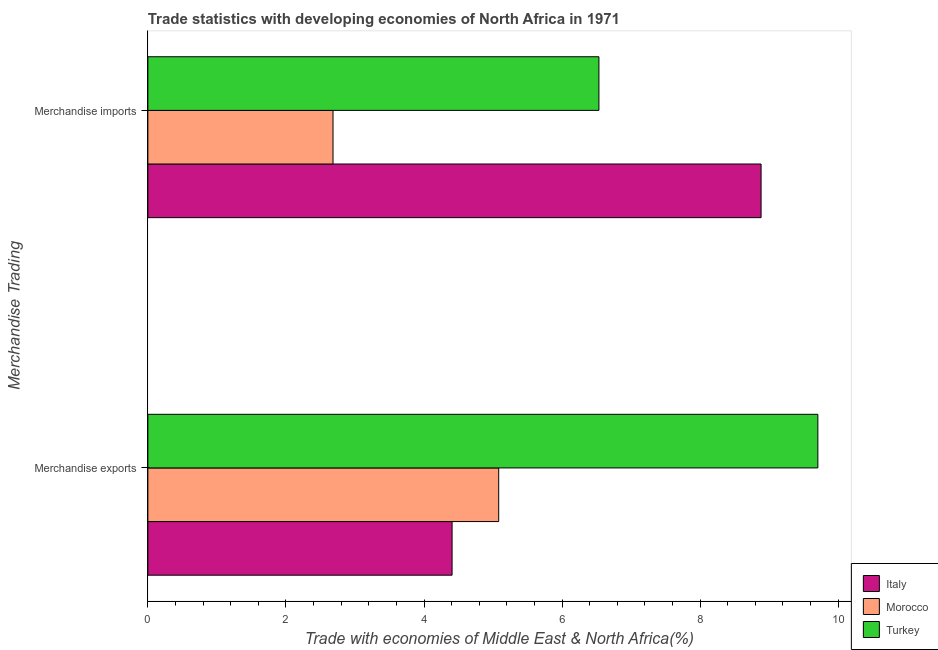How many different coloured bars are there?
Ensure brevity in your answer.  3. How many groups of bars are there?
Offer a terse response. 2. Are the number of bars per tick equal to the number of legend labels?
Offer a very short reply. Yes. How many bars are there on the 1st tick from the top?
Provide a short and direct response. 3. How many bars are there on the 1st tick from the bottom?
Your response must be concise. 3. What is the merchandise exports in Morocco?
Give a very brief answer. 5.08. Across all countries, what is the maximum merchandise exports?
Your answer should be compact. 9.71. Across all countries, what is the minimum merchandise imports?
Give a very brief answer. 2.68. In which country was the merchandise exports maximum?
Make the answer very short. Turkey. In which country was the merchandise imports minimum?
Keep it short and to the point. Morocco. What is the total merchandise imports in the graph?
Make the answer very short. 18.1. What is the difference between the merchandise imports in Turkey and that in Italy?
Your answer should be very brief. -2.35. What is the difference between the merchandise exports in Morocco and the merchandise imports in Italy?
Provide a short and direct response. -3.8. What is the average merchandise exports per country?
Make the answer very short. 6.4. What is the difference between the merchandise exports and merchandise imports in Morocco?
Offer a terse response. 2.4. In how many countries, is the merchandise exports greater than 1.2000000000000002 %?
Provide a succinct answer. 3. What is the ratio of the merchandise exports in Italy to that in Morocco?
Your response must be concise. 0.87. In how many countries, is the merchandise exports greater than the average merchandise exports taken over all countries?
Make the answer very short. 1. What does the 1st bar from the bottom in Merchandise exports represents?
Provide a succinct answer. Italy. How many bars are there?
Keep it short and to the point. 6. What is the difference between two consecutive major ticks on the X-axis?
Offer a terse response. 2. Are the values on the major ticks of X-axis written in scientific E-notation?
Give a very brief answer. No. Does the graph contain any zero values?
Keep it short and to the point. No. Does the graph contain grids?
Keep it short and to the point. No. How are the legend labels stacked?
Offer a very short reply. Vertical. What is the title of the graph?
Give a very brief answer. Trade statistics with developing economies of North Africa in 1971. Does "Kazakhstan" appear as one of the legend labels in the graph?
Your answer should be very brief. No. What is the label or title of the X-axis?
Provide a short and direct response. Trade with economies of Middle East & North Africa(%). What is the label or title of the Y-axis?
Offer a terse response. Merchandise Trading. What is the Trade with economies of Middle East & North Africa(%) of Italy in Merchandise exports?
Your response must be concise. 4.41. What is the Trade with economies of Middle East & North Africa(%) in Morocco in Merchandise exports?
Offer a terse response. 5.08. What is the Trade with economies of Middle East & North Africa(%) in Turkey in Merchandise exports?
Keep it short and to the point. 9.71. What is the Trade with economies of Middle East & North Africa(%) of Italy in Merchandise imports?
Make the answer very short. 8.88. What is the Trade with economies of Middle East & North Africa(%) of Morocco in Merchandise imports?
Provide a short and direct response. 2.68. What is the Trade with economies of Middle East & North Africa(%) in Turkey in Merchandise imports?
Offer a very short reply. 6.53. Across all Merchandise Trading, what is the maximum Trade with economies of Middle East & North Africa(%) in Italy?
Offer a very short reply. 8.88. Across all Merchandise Trading, what is the maximum Trade with economies of Middle East & North Africa(%) in Morocco?
Keep it short and to the point. 5.08. Across all Merchandise Trading, what is the maximum Trade with economies of Middle East & North Africa(%) in Turkey?
Ensure brevity in your answer.  9.71. Across all Merchandise Trading, what is the minimum Trade with economies of Middle East & North Africa(%) of Italy?
Your response must be concise. 4.41. Across all Merchandise Trading, what is the minimum Trade with economies of Middle East & North Africa(%) in Morocco?
Offer a very short reply. 2.68. Across all Merchandise Trading, what is the minimum Trade with economies of Middle East & North Africa(%) of Turkey?
Provide a short and direct response. 6.53. What is the total Trade with economies of Middle East & North Africa(%) of Italy in the graph?
Make the answer very short. 13.29. What is the total Trade with economies of Middle East & North Africa(%) in Morocco in the graph?
Your answer should be compact. 7.76. What is the total Trade with economies of Middle East & North Africa(%) of Turkey in the graph?
Provide a succinct answer. 16.24. What is the difference between the Trade with economies of Middle East & North Africa(%) in Italy in Merchandise exports and that in Merchandise imports?
Offer a very short reply. -4.48. What is the difference between the Trade with economies of Middle East & North Africa(%) of Morocco in Merchandise exports and that in Merchandise imports?
Provide a short and direct response. 2.4. What is the difference between the Trade with economies of Middle East & North Africa(%) of Turkey in Merchandise exports and that in Merchandise imports?
Your answer should be compact. 3.17. What is the difference between the Trade with economies of Middle East & North Africa(%) of Italy in Merchandise exports and the Trade with economies of Middle East & North Africa(%) of Morocco in Merchandise imports?
Provide a short and direct response. 1.72. What is the difference between the Trade with economies of Middle East & North Africa(%) of Italy in Merchandise exports and the Trade with economies of Middle East & North Africa(%) of Turkey in Merchandise imports?
Offer a terse response. -2.13. What is the difference between the Trade with economies of Middle East & North Africa(%) of Morocco in Merchandise exports and the Trade with economies of Middle East & North Africa(%) of Turkey in Merchandise imports?
Your response must be concise. -1.45. What is the average Trade with economies of Middle East & North Africa(%) in Italy per Merchandise Trading?
Provide a short and direct response. 6.64. What is the average Trade with economies of Middle East & North Africa(%) of Morocco per Merchandise Trading?
Ensure brevity in your answer.  3.88. What is the average Trade with economies of Middle East & North Africa(%) in Turkey per Merchandise Trading?
Your response must be concise. 8.12. What is the difference between the Trade with economies of Middle East & North Africa(%) in Italy and Trade with economies of Middle East & North Africa(%) in Morocco in Merchandise exports?
Your response must be concise. -0.68. What is the difference between the Trade with economies of Middle East & North Africa(%) of Italy and Trade with economies of Middle East & North Africa(%) of Turkey in Merchandise exports?
Keep it short and to the point. -5.3. What is the difference between the Trade with economies of Middle East & North Africa(%) in Morocco and Trade with economies of Middle East & North Africa(%) in Turkey in Merchandise exports?
Keep it short and to the point. -4.62. What is the difference between the Trade with economies of Middle East & North Africa(%) in Italy and Trade with economies of Middle East & North Africa(%) in Morocco in Merchandise imports?
Ensure brevity in your answer.  6.2. What is the difference between the Trade with economies of Middle East & North Africa(%) of Italy and Trade with economies of Middle East & North Africa(%) of Turkey in Merchandise imports?
Offer a very short reply. 2.35. What is the difference between the Trade with economies of Middle East & North Africa(%) in Morocco and Trade with economies of Middle East & North Africa(%) in Turkey in Merchandise imports?
Your answer should be very brief. -3.85. What is the ratio of the Trade with economies of Middle East & North Africa(%) in Italy in Merchandise exports to that in Merchandise imports?
Your answer should be very brief. 0.5. What is the ratio of the Trade with economies of Middle East & North Africa(%) of Morocco in Merchandise exports to that in Merchandise imports?
Offer a terse response. 1.89. What is the ratio of the Trade with economies of Middle East & North Africa(%) of Turkey in Merchandise exports to that in Merchandise imports?
Your response must be concise. 1.49. What is the difference between the highest and the second highest Trade with economies of Middle East & North Africa(%) of Italy?
Offer a very short reply. 4.48. What is the difference between the highest and the second highest Trade with economies of Middle East & North Africa(%) in Morocco?
Keep it short and to the point. 2.4. What is the difference between the highest and the second highest Trade with economies of Middle East & North Africa(%) in Turkey?
Your answer should be very brief. 3.17. What is the difference between the highest and the lowest Trade with economies of Middle East & North Africa(%) in Italy?
Give a very brief answer. 4.48. What is the difference between the highest and the lowest Trade with economies of Middle East & North Africa(%) of Turkey?
Your answer should be compact. 3.17. 